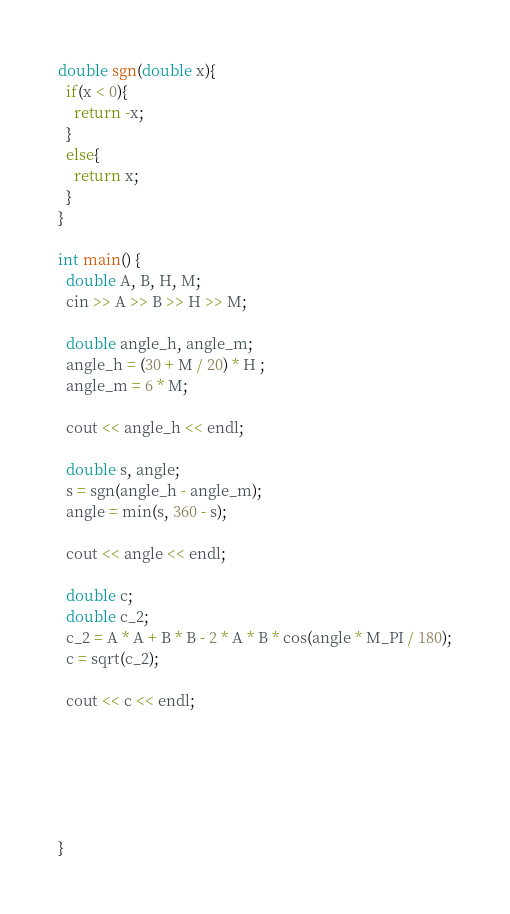<code> <loc_0><loc_0><loc_500><loc_500><_C++_>
double sgn(double x){
  if(x < 0){
    return -x;
  }
  else{
    return x;
  }
}

int main() {
  double A, B, H, M;
  cin >> A >> B >> H >> M;
  
  double angle_h, angle_m;
  angle_h = (30 + M / 20) * H ;
  angle_m = 6 * M;
  
  cout << angle_h << endl;
  
  double s, angle;
  s = sgn(angle_h - angle_m);
  angle = min(s, 360 - s);
  
  cout << angle << endl;
  
  double c;
  double c_2;
  c_2 = A * A + B * B - 2 * A * B * cos(angle * M_PI / 180);
  c = sqrt(c_2);
  
  cout << c << endl;
  
  
  

 
  
}</code> 